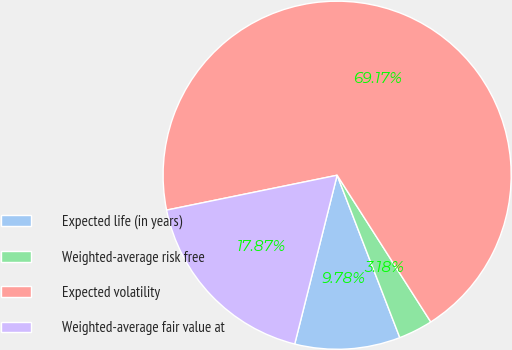Convert chart to OTSL. <chart><loc_0><loc_0><loc_500><loc_500><pie_chart><fcel>Expected life (in years)<fcel>Weighted-average risk free<fcel>Expected volatility<fcel>Weighted-average fair value at<nl><fcel>9.78%<fcel>3.18%<fcel>69.17%<fcel>17.87%<nl></chart> 